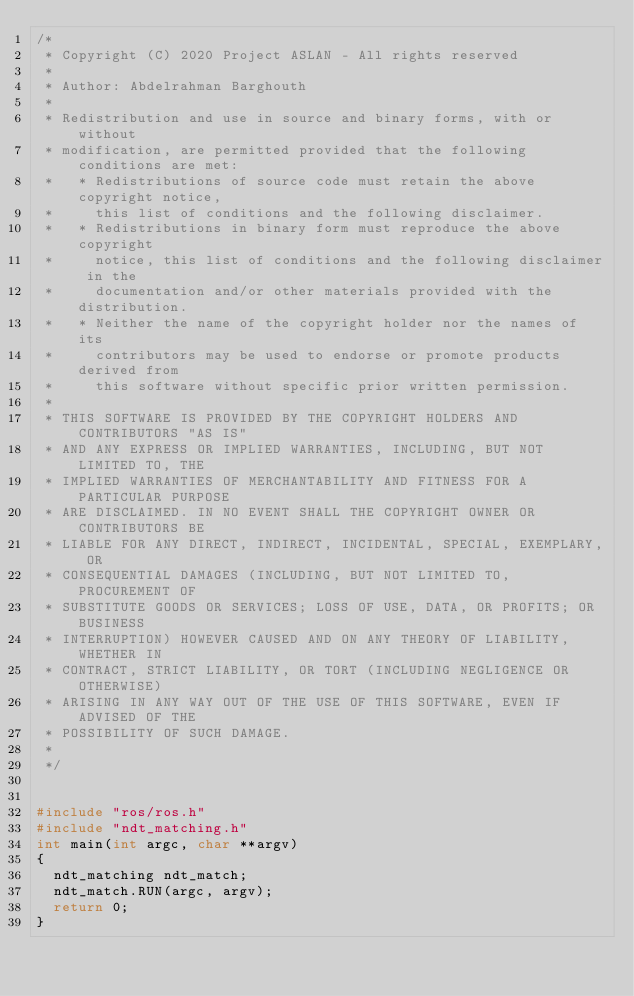Convert code to text. <code><loc_0><loc_0><loc_500><loc_500><_C++_>/*
 * Copyright (C) 2020 Project ASLAN - All rights reserved
 *
 * Author: Abdelrahman Barghouth
 *
 * Redistribution and use in source and binary forms, with or without
 * modification, are permitted provided that the following conditions are met:
 *   * Redistributions of source code must retain the above copyright notice,
 *     this list of conditions and the following disclaimer.
 *   * Redistributions in binary form must reproduce the above copyright
 *     notice, this list of conditions and the following disclaimer in the
 *     documentation and/or other materials provided with the distribution.
 *   * Neither the name of the copyright holder nor the names of its
 *     contributors may be used to endorse or promote products derived from
 *     this software without specific prior written permission.
 *
 * THIS SOFTWARE IS PROVIDED BY THE COPYRIGHT HOLDERS AND CONTRIBUTORS "AS IS"
 * AND ANY EXPRESS OR IMPLIED WARRANTIES, INCLUDING, BUT NOT LIMITED TO, THE
 * IMPLIED WARRANTIES OF MERCHANTABILITY AND FITNESS FOR A PARTICULAR PURPOSE
 * ARE DISCLAIMED. IN NO EVENT SHALL THE COPYRIGHT OWNER OR CONTRIBUTORS BE
 * LIABLE FOR ANY DIRECT, INDIRECT, INCIDENTAL, SPECIAL, EXEMPLARY, OR
 * CONSEQUENTIAL DAMAGES (INCLUDING, BUT NOT LIMITED TO, PROCUREMENT OF
 * SUBSTITUTE GOODS OR SERVICES; LOSS OF USE, DATA, OR PROFITS; OR BUSINESS
 * INTERRUPTION) HOWEVER CAUSED AND ON ANY THEORY OF LIABILITY, WHETHER IN
 * CONTRACT, STRICT LIABILITY, OR TORT (INCLUDING NEGLIGENCE OR OTHERWISE)
 * ARISING IN ANY WAY OUT OF THE USE OF THIS SOFTWARE, EVEN IF ADVISED OF THE
 * POSSIBILITY OF SUCH DAMAGE.
 *
 */


#include "ros/ros.h"
#include "ndt_matching.h"
int main(int argc, char **argv)
{
	ndt_matching ndt_match;
	ndt_match.RUN(argc, argv);
	return 0;
}</code> 